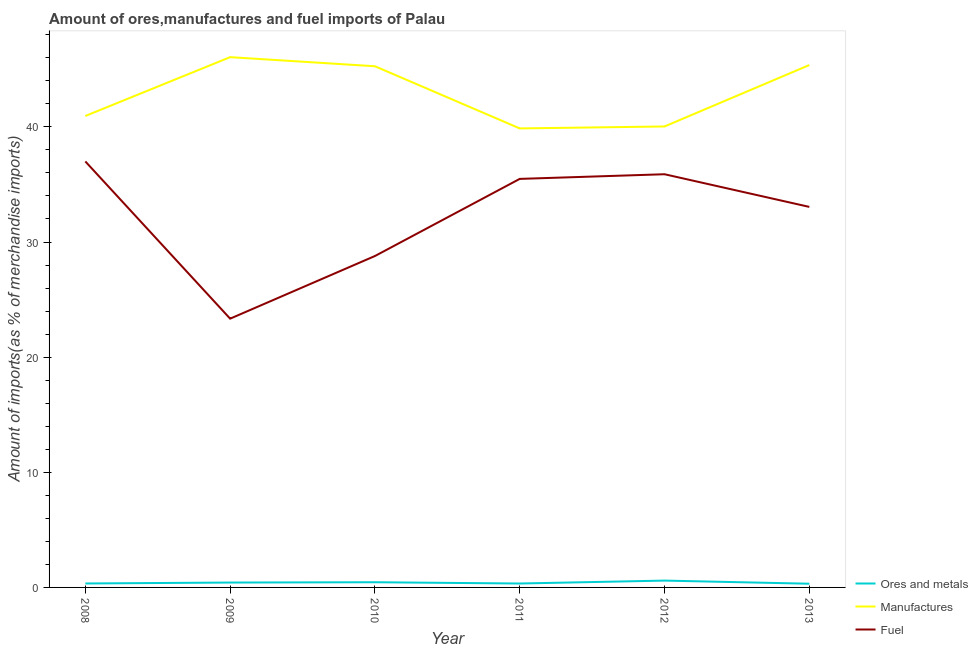How many different coloured lines are there?
Your answer should be very brief. 3. What is the percentage of fuel imports in 2012?
Provide a succinct answer. 35.89. Across all years, what is the maximum percentage of fuel imports?
Give a very brief answer. 37. Across all years, what is the minimum percentage of fuel imports?
Offer a very short reply. 23.34. In which year was the percentage of fuel imports maximum?
Provide a succinct answer. 2008. In which year was the percentage of manufactures imports minimum?
Make the answer very short. 2011. What is the total percentage of manufactures imports in the graph?
Offer a terse response. 257.54. What is the difference between the percentage of ores and metals imports in 2009 and that in 2010?
Your answer should be very brief. -0.03. What is the difference between the percentage of fuel imports in 2011 and the percentage of manufactures imports in 2009?
Make the answer very short. -10.57. What is the average percentage of fuel imports per year?
Your answer should be very brief. 32.26. In the year 2009, what is the difference between the percentage of manufactures imports and percentage of fuel imports?
Your response must be concise. 22.71. What is the ratio of the percentage of fuel imports in 2008 to that in 2009?
Offer a very short reply. 1.59. What is the difference between the highest and the second highest percentage of manufactures imports?
Keep it short and to the point. 0.69. What is the difference between the highest and the lowest percentage of manufactures imports?
Provide a succinct answer. 6.19. In how many years, is the percentage of manufactures imports greater than the average percentage of manufactures imports taken over all years?
Your response must be concise. 3. Does the percentage of manufactures imports monotonically increase over the years?
Your answer should be very brief. No. Is the percentage of ores and metals imports strictly greater than the percentage of fuel imports over the years?
Your answer should be very brief. No. How many years are there in the graph?
Your answer should be compact. 6. Are the values on the major ticks of Y-axis written in scientific E-notation?
Ensure brevity in your answer.  No. Does the graph contain any zero values?
Make the answer very short. No. Does the graph contain grids?
Your answer should be compact. No. Where does the legend appear in the graph?
Offer a very short reply. Bottom right. How many legend labels are there?
Give a very brief answer. 3. What is the title of the graph?
Your answer should be compact. Amount of ores,manufactures and fuel imports of Palau. What is the label or title of the Y-axis?
Keep it short and to the point. Amount of imports(as % of merchandise imports). What is the Amount of imports(as % of merchandise imports) in Ores and metals in 2008?
Provide a succinct answer. 0.34. What is the Amount of imports(as % of merchandise imports) of Manufactures in 2008?
Your answer should be compact. 40.95. What is the Amount of imports(as % of merchandise imports) of Fuel in 2008?
Your answer should be compact. 37. What is the Amount of imports(as % of merchandise imports) of Ores and metals in 2009?
Offer a terse response. 0.42. What is the Amount of imports(as % of merchandise imports) in Manufactures in 2009?
Make the answer very short. 46.06. What is the Amount of imports(as % of merchandise imports) of Fuel in 2009?
Give a very brief answer. 23.34. What is the Amount of imports(as % of merchandise imports) in Ores and metals in 2010?
Provide a short and direct response. 0.45. What is the Amount of imports(as % of merchandise imports) of Manufactures in 2010?
Ensure brevity in your answer.  45.27. What is the Amount of imports(as % of merchandise imports) in Fuel in 2010?
Your answer should be compact. 28.78. What is the Amount of imports(as % of merchandise imports) in Ores and metals in 2011?
Your response must be concise. 0.34. What is the Amount of imports(as % of merchandise imports) of Manufactures in 2011?
Make the answer very short. 39.87. What is the Amount of imports(as % of merchandise imports) in Fuel in 2011?
Keep it short and to the point. 35.48. What is the Amount of imports(as % of merchandise imports) in Ores and metals in 2012?
Ensure brevity in your answer.  0.59. What is the Amount of imports(as % of merchandise imports) of Manufactures in 2012?
Offer a terse response. 40.04. What is the Amount of imports(as % of merchandise imports) of Fuel in 2012?
Offer a very short reply. 35.89. What is the Amount of imports(as % of merchandise imports) of Ores and metals in 2013?
Ensure brevity in your answer.  0.32. What is the Amount of imports(as % of merchandise imports) of Manufactures in 2013?
Give a very brief answer. 45.37. What is the Amount of imports(as % of merchandise imports) in Fuel in 2013?
Ensure brevity in your answer.  33.05. Across all years, what is the maximum Amount of imports(as % of merchandise imports) of Ores and metals?
Provide a succinct answer. 0.59. Across all years, what is the maximum Amount of imports(as % of merchandise imports) of Manufactures?
Offer a very short reply. 46.06. Across all years, what is the maximum Amount of imports(as % of merchandise imports) of Fuel?
Provide a succinct answer. 37. Across all years, what is the minimum Amount of imports(as % of merchandise imports) of Ores and metals?
Give a very brief answer. 0.32. Across all years, what is the minimum Amount of imports(as % of merchandise imports) of Manufactures?
Your answer should be very brief. 39.87. Across all years, what is the minimum Amount of imports(as % of merchandise imports) in Fuel?
Give a very brief answer. 23.34. What is the total Amount of imports(as % of merchandise imports) of Ores and metals in the graph?
Provide a short and direct response. 2.47. What is the total Amount of imports(as % of merchandise imports) in Manufactures in the graph?
Your answer should be compact. 257.54. What is the total Amount of imports(as % of merchandise imports) of Fuel in the graph?
Give a very brief answer. 193.55. What is the difference between the Amount of imports(as % of merchandise imports) in Ores and metals in 2008 and that in 2009?
Ensure brevity in your answer.  -0.08. What is the difference between the Amount of imports(as % of merchandise imports) in Manufactures in 2008 and that in 2009?
Your answer should be compact. -5.11. What is the difference between the Amount of imports(as % of merchandise imports) of Fuel in 2008 and that in 2009?
Offer a very short reply. 13.66. What is the difference between the Amount of imports(as % of merchandise imports) of Ores and metals in 2008 and that in 2010?
Your response must be concise. -0.11. What is the difference between the Amount of imports(as % of merchandise imports) of Manufactures in 2008 and that in 2010?
Offer a terse response. -4.32. What is the difference between the Amount of imports(as % of merchandise imports) of Fuel in 2008 and that in 2010?
Provide a succinct answer. 8.21. What is the difference between the Amount of imports(as % of merchandise imports) in Ores and metals in 2008 and that in 2011?
Offer a terse response. 0. What is the difference between the Amount of imports(as % of merchandise imports) in Manufactures in 2008 and that in 2011?
Offer a very short reply. 1.08. What is the difference between the Amount of imports(as % of merchandise imports) in Fuel in 2008 and that in 2011?
Offer a terse response. 1.52. What is the difference between the Amount of imports(as % of merchandise imports) of Ores and metals in 2008 and that in 2012?
Give a very brief answer. -0.25. What is the difference between the Amount of imports(as % of merchandise imports) in Manufactures in 2008 and that in 2012?
Make the answer very short. 0.91. What is the difference between the Amount of imports(as % of merchandise imports) of Fuel in 2008 and that in 2012?
Ensure brevity in your answer.  1.11. What is the difference between the Amount of imports(as % of merchandise imports) in Ores and metals in 2008 and that in 2013?
Your answer should be very brief. 0.02. What is the difference between the Amount of imports(as % of merchandise imports) of Manufactures in 2008 and that in 2013?
Offer a terse response. -4.42. What is the difference between the Amount of imports(as % of merchandise imports) in Fuel in 2008 and that in 2013?
Your answer should be very brief. 3.95. What is the difference between the Amount of imports(as % of merchandise imports) in Ores and metals in 2009 and that in 2010?
Your answer should be very brief. -0.03. What is the difference between the Amount of imports(as % of merchandise imports) in Manufactures in 2009 and that in 2010?
Offer a very short reply. 0.79. What is the difference between the Amount of imports(as % of merchandise imports) in Fuel in 2009 and that in 2010?
Provide a succinct answer. -5.44. What is the difference between the Amount of imports(as % of merchandise imports) in Ores and metals in 2009 and that in 2011?
Provide a short and direct response. 0.08. What is the difference between the Amount of imports(as % of merchandise imports) in Manufactures in 2009 and that in 2011?
Provide a short and direct response. 6.19. What is the difference between the Amount of imports(as % of merchandise imports) in Fuel in 2009 and that in 2011?
Ensure brevity in your answer.  -12.14. What is the difference between the Amount of imports(as % of merchandise imports) of Ores and metals in 2009 and that in 2012?
Make the answer very short. -0.17. What is the difference between the Amount of imports(as % of merchandise imports) of Manufactures in 2009 and that in 2012?
Make the answer very short. 6.02. What is the difference between the Amount of imports(as % of merchandise imports) in Fuel in 2009 and that in 2012?
Make the answer very short. -12.54. What is the difference between the Amount of imports(as % of merchandise imports) in Ores and metals in 2009 and that in 2013?
Give a very brief answer. 0.1. What is the difference between the Amount of imports(as % of merchandise imports) of Manufactures in 2009 and that in 2013?
Offer a terse response. 0.69. What is the difference between the Amount of imports(as % of merchandise imports) in Fuel in 2009 and that in 2013?
Provide a succinct answer. -9.71. What is the difference between the Amount of imports(as % of merchandise imports) in Ores and metals in 2010 and that in 2011?
Keep it short and to the point. 0.11. What is the difference between the Amount of imports(as % of merchandise imports) of Manufactures in 2010 and that in 2011?
Keep it short and to the point. 5.4. What is the difference between the Amount of imports(as % of merchandise imports) of Fuel in 2010 and that in 2011?
Give a very brief answer. -6.7. What is the difference between the Amount of imports(as % of merchandise imports) of Ores and metals in 2010 and that in 2012?
Give a very brief answer. -0.14. What is the difference between the Amount of imports(as % of merchandise imports) in Manufactures in 2010 and that in 2012?
Make the answer very short. 5.23. What is the difference between the Amount of imports(as % of merchandise imports) of Fuel in 2010 and that in 2012?
Ensure brevity in your answer.  -7.1. What is the difference between the Amount of imports(as % of merchandise imports) in Ores and metals in 2010 and that in 2013?
Provide a succinct answer. 0.13. What is the difference between the Amount of imports(as % of merchandise imports) of Manufactures in 2010 and that in 2013?
Your response must be concise. -0.1. What is the difference between the Amount of imports(as % of merchandise imports) of Fuel in 2010 and that in 2013?
Give a very brief answer. -4.27. What is the difference between the Amount of imports(as % of merchandise imports) in Ores and metals in 2011 and that in 2012?
Provide a succinct answer. -0.25. What is the difference between the Amount of imports(as % of merchandise imports) of Manufactures in 2011 and that in 2012?
Ensure brevity in your answer.  -0.17. What is the difference between the Amount of imports(as % of merchandise imports) of Fuel in 2011 and that in 2012?
Your answer should be compact. -0.4. What is the difference between the Amount of imports(as % of merchandise imports) in Ores and metals in 2011 and that in 2013?
Make the answer very short. 0.02. What is the difference between the Amount of imports(as % of merchandise imports) of Manufactures in 2011 and that in 2013?
Your response must be concise. -5.5. What is the difference between the Amount of imports(as % of merchandise imports) of Fuel in 2011 and that in 2013?
Make the answer very short. 2.43. What is the difference between the Amount of imports(as % of merchandise imports) in Ores and metals in 2012 and that in 2013?
Provide a short and direct response. 0.27. What is the difference between the Amount of imports(as % of merchandise imports) in Manufactures in 2012 and that in 2013?
Offer a terse response. -5.33. What is the difference between the Amount of imports(as % of merchandise imports) of Fuel in 2012 and that in 2013?
Give a very brief answer. 2.84. What is the difference between the Amount of imports(as % of merchandise imports) in Ores and metals in 2008 and the Amount of imports(as % of merchandise imports) in Manufactures in 2009?
Offer a very short reply. -45.71. What is the difference between the Amount of imports(as % of merchandise imports) of Ores and metals in 2008 and the Amount of imports(as % of merchandise imports) of Fuel in 2009?
Offer a terse response. -23. What is the difference between the Amount of imports(as % of merchandise imports) of Manufactures in 2008 and the Amount of imports(as % of merchandise imports) of Fuel in 2009?
Your answer should be compact. 17.6. What is the difference between the Amount of imports(as % of merchandise imports) in Ores and metals in 2008 and the Amount of imports(as % of merchandise imports) in Manufactures in 2010?
Make the answer very short. -44.92. What is the difference between the Amount of imports(as % of merchandise imports) in Ores and metals in 2008 and the Amount of imports(as % of merchandise imports) in Fuel in 2010?
Offer a terse response. -28.44. What is the difference between the Amount of imports(as % of merchandise imports) in Manufactures in 2008 and the Amount of imports(as % of merchandise imports) in Fuel in 2010?
Give a very brief answer. 12.16. What is the difference between the Amount of imports(as % of merchandise imports) in Ores and metals in 2008 and the Amount of imports(as % of merchandise imports) in Manufactures in 2011?
Your answer should be compact. -39.52. What is the difference between the Amount of imports(as % of merchandise imports) of Ores and metals in 2008 and the Amount of imports(as % of merchandise imports) of Fuel in 2011?
Make the answer very short. -35.14. What is the difference between the Amount of imports(as % of merchandise imports) in Manufactures in 2008 and the Amount of imports(as % of merchandise imports) in Fuel in 2011?
Make the answer very short. 5.46. What is the difference between the Amount of imports(as % of merchandise imports) in Ores and metals in 2008 and the Amount of imports(as % of merchandise imports) in Manufactures in 2012?
Your response must be concise. -39.69. What is the difference between the Amount of imports(as % of merchandise imports) of Ores and metals in 2008 and the Amount of imports(as % of merchandise imports) of Fuel in 2012?
Offer a very short reply. -35.55. What is the difference between the Amount of imports(as % of merchandise imports) in Manufactures in 2008 and the Amount of imports(as % of merchandise imports) in Fuel in 2012?
Keep it short and to the point. 5.06. What is the difference between the Amount of imports(as % of merchandise imports) in Ores and metals in 2008 and the Amount of imports(as % of merchandise imports) in Manufactures in 2013?
Keep it short and to the point. -45.03. What is the difference between the Amount of imports(as % of merchandise imports) of Ores and metals in 2008 and the Amount of imports(as % of merchandise imports) of Fuel in 2013?
Your answer should be compact. -32.71. What is the difference between the Amount of imports(as % of merchandise imports) of Manufactures in 2008 and the Amount of imports(as % of merchandise imports) of Fuel in 2013?
Provide a short and direct response. 7.9. What is the difference between the Amount of imports(as % of merchandise imports) in Ores and metals in 2009 and the Amount of imports(as % of merchandise imports) in Manufactures in 2010?
Offer a terse response. -44.84. What is the difference between the Amount of imports(as % of merchandise imports) in Ores and metals in 2009 and the Amount of imports(as % of merchandise imports) in Fuel in 2010?
Offer a very short reply. -28.36. What is the difference between the Amount of imports(as % of merchandise imports) in Manufactures in 2009 and the Amount of imports(as % of merchandise imports) in Fuel in 2010?
Make the answer very short. 17.27. What is the difference between the Amount of imports(as % of merchandise imports) of Ores and metals in 2009 and the Amount of imports(as % of merchandise imports) of Manufactures in 2011?
Ensure brevity in your answer.  -39.44. What is the difference between the Amount of imports(as % of merchandise imports) in Ores and metals in 2009 and the Amount of imports(as % of merchandise imports) in Fuel in 2011?
Ensure brevity in your answer.  -35.06. What is the difference between the Amount of imports(as % of merchandise imports) in Manufactures in 2009 and the Amount of imports(as % of merchandise imports) in Fuel in 2011?
Provide a succinct answer. 10.57. What is the difference between the Amount of imports(as % of merchandise imports) in Ores and metals in 2009 and the Amount of imports(as % of merchandise imports) in Manufactures in 2012?
Your answer should be compact. -39.61. What is the difference between the Amount of imports(as % of merchandise imports) in Ores and metals in 2009 and the Amount of imports(as % of merchandise imports) in Fuel in 2012?
Make the answer very short. -35.46. What is the difference between the Amount of imports(as % of merchandise imports) in Manufactures in 2009 and the Amount of imports(as % of merchandise imports) in Fuel in 2012?
Your response must be concise. 10.17. What is the difference between the Amount of imports(as % of merchandise imports) of Ores and metals in 2009 and the Amount of imports(as % of merchandise imports) of Manufactures in 2013?
Offer a very short reply. -44.95. What is the difference between the Amount of imports(as % of merchandise imports) of Ores and metals in 2009 and the Amount of imports(as % of merchandise imports) of Fuel in 2013?
Offer a terse response. -32.63. What is the difference between the Amount of imports(as % of merchandise imports) in Manufactures in 2009 and the Amount of imports(as % of merchandise imports) in Fuel in 2013?
Your answer should be compact. 13.01. What is the difference between the Amount of imports(as % of merchandise imports) in Ores and metals in 2010 and the Amount of imports(as % of merchandise imports) in Manufactures in 2011?
Make the answer very short. -39.42. What is the difference between the Amount of imports(as % of merchandise imports) in Ores and metals in 2010 and the Amount of imports(as % of merchandise imports) in Fuel in 2011?
Provide a short and direct response. -35.03. What is the difference between the Amount of imports(as % of merchandise imports) in Manufactures in 2010 and the Amount of imports(as % of merchandise imports) in Fuel in 2011?
Keep it short and to the point. 9.78. What is the difference between the Amount of imports(as % of merchandise imports) of Ores and metals in 2010 and the Amount of imports(as % of merchandise imports) of Manufactures in 2012?
Ensure brevity in your answer.  -39.59. What is the difference between the Amount of imports(as % of merchandise imports) of Ores and metals in 2010 and the Amount of imports(as % of merchandise imports) of Fuel in 2012?
Provide a succinct answer. -35.44. What is the difference between the Amount of imports(as % of merchandise imports) of Manufactures in 2010 and the Amount of imports(as % of merchandise imports) of Fuel in 2012?
Your answer should be very brief. 9.38. What is the difference between the Amount of imports(as % of merchandise imports) in Ores and metals in 2010 and the Amount of imports(as % of merchandise imports) in Manufactures in 2013?
Keep it short and to the point. -44.92. What is the difference between the Amount of imports(as % of merchandise imports) of Ores and metals in 2010 and the Amount of imports(as % of merchandise imports) of Fuel in 2013?
Offer a terse response. -32.6. What is the difference between the Amount of imports(as % of merchandise imports) of Manufactures in 2010 and the Amount of imports(as % of merchandise imports) of Fuel in 2013?
Your answer should be compact. 12.22. What is the difference between the Amount of imports(as % of merchandise imports) in Ores and metals in 2011 and the Amount of imports(as % of merchandise imports) in Manufactures in 2012?
Provide a succinct answer. -39.7. What is the difference between the Amount of imports(as % of merchandise imports) of Ores and metals in 2011 and the Amount of imports(as % of merchandise imports) of Fuel in 2012?
Give a very brief answer. -35.55. What is the difference between the Amount of imports(as % of merchandise imports) in Manufactures in 2011 and the Amount of imports(as % of merchandise imports) in Fuel in 2012?
Offer a very short reply. 3.98. What is the difference between the Amount of imports(as % of merchandise imports) of Ores and metals in 2011 and the Amount of imports(as % of merchandise imports) of Manufactures in 2013?
Offer a terse response. -45.03. What is the difference between the Amount of imports(as % of merchandise imports) in Ores and metals in 2011 and the Amount of imports(as % of merchandise imports) in Fuel in 2013?
Provide a short and direct response. -32.71. What is the difference between the Amount of imports(as % of merchandise imports) of Manufactures in 2011 and the Amount of imports(as % of merchandise imports) of Fuel in 2013?
Your answer should be very brief. 6.82. What is the difference between the Amount of imports(as % of merchandise imports) in Ores and metals in 2012 and the Amount of imports(as % of merchandise imports) in Manufactures in 2013?
Provide a succinct answer. -44.78. What is the difference between the Amount of imports(as % of merchandise imports) in Ores and metals in 2012 and the Amount of imports(as % of merchandise imports) in Fuel in 2013?
Your response must be concise. -32.46. What is the difference between the Amount of imports(as % of merchandise imports) of Manufactures in 2012 and the Amount of imports(as % of merchandise imports) of Fuel in 2013?
Offer a terse response. 6.99. What is the average Amount of imports(as % of merchandise imports) of Ores and metals per year?
Keep it short and to the point. 0.41. What is the average Amount of imports(as % of merchandise imports) in Manufactures per year?
Your answer should be compact. 42.92. What is the average Amount of imports(as % of merchandise imports) in Fuel per year?
Ensure brevity in your answer.  32.26. In the year 2008, what is the difference between the Amount of imports(as % of merchandise imports) of Ores and metals and Amount of imports(as % of merchandise imports) of Manufactures?
Make the answer very short. -40.61. In the year 2008, what is the difference between the Amount of imports(as % of merchandise imports) of Ores and metals and Amount of imports(as % of merchandise imports) of Fuel?
Your response must be concise. -36.66. In the year 2008, what is the difference between the Amount of imports(as % of merchandise imports) of Manufactures and Amount of imports(as % of merchandise imports) of Fuel?
Your response must be concise. 3.95. In the year 2009, what is the difference between the Amount of imports(as % of merchandise imports) in Ores and metals and Amount of imports(as % of merchandise imports) in Manufactures?
Provide a short and direct response. -45.63. In the year 2009, what is the difference between the Amount of imports(as % of merchandise imports) in Ores and metals and Amount of imports(as % of merchandise imports) in Fuel?
Keep it short and to the point. -22.92. In the year 2009, what is the difference between the Amount of imports(as % of merchandise imports) in Manufactures and Amount of imports(as % of merchandise imports) in Fuel?
Offer a terse response. 22.71. In the year 2010, what is the difference between the Amount of imports(as % of merchandise imports) of Ores and metals and Amount of imports(as % of merchandise imports) of Manufactures?
Provide a short and direct response. -44.82. In the year 2010, what is the difference between the Amount of imports(as % of merchandise imports) of Ores and metals and Amount of imports(as % of merchandise imports) of Fuel?
Provide a succinct answer. -28.33. In the year 2010, what is the difference between the Amount of imports(as % of merchandise imports) in Manufactures and Amount of imports(as % of merchandise imports) in Fuel?
Offer a very short reply. 16.48. In the year 2011, what is the difference between the Amount of imports(as % of merchandise imports) of Ores and metals and Amount of imports(as % of merchandise imports) of Manufactures?
Keep it short and to the point. -39.53. In the year 2011, what is the difference between the Amount of imports(as % of merchandise imports) of Ores and metals and Amount of imports(as % of merchandise imports) of Fuel?
Your response must be concise. -35.14. In the year 2011, what is the difference between the Amount of imports(as % of merchandise imports) in Manufactures and Amount of imports(as % of merchandise imports) in Fuel?
Offer a very short reply. 4.38. In the year 2012, what is the difference between the Amount of imports(as % of merchandise imports) in Ores and metals and Amount of imports(as % of merchandise imports) in Manufactures?
Ensure brevity in your answer.  -39.44. In the year 2012, what is the difference between the Amount of imports(as % of merchandise imports) of Ores and metals and Amount of imports(as % of merchandise imports) of Fuel?
Make the answer very short. -35.29. In the year 2012, what is the difference between the Amount of imports(as % of merchandise imports) in Manufactures and Amount of imports(as % of merchandise imports) in Fuel?
Offer a very short reply. 4.15. In the year 2013, what is the difference between the Amount of imports(as % of merchandise imports) in Ores and metals and Amount of imports(as % of merchandise imports) in Manufactures?
Your answer should be very brief. -45.05. In the year 2013, what is the difference between the Amount of imports(as % of merchandise imports) of Ores and metals and Amount of imports(as % of merchandise imports) of Fuel?
Your response must be concise. -32.73. In the year 2013, what is the difference between the Amount of imports(as % of merchandise imports) in Manufactures and Amount of imports(as % of merchandise imports) in Fuel?
Ensure brevity in your answer.  12.32. What is the ratio of the Amount of imports(as % of merchandise imports) in Ores and metals in 2008 to that in 2009?
Ensure brevity in your answer.  0.81. What is the ratio of the Amount of imports(as % of merchandise imports) in Manufactures in 2008 to that in 2009?
Your answer should be compact. 0.89. What is the ratio of the Amount of imports(as % of merchandise imports) in Fuel in 2008 to that in 2009?
Keep it short and to the point. 1.58. What is the ratio of the Amount of imports(as % of merchandise imports) of Ores and metals in 2008 to that in 2010?
Provide a succinct answer. 0.76. What is the ratio of the Amount of imports(as % of merchandise imports) in Manufactures in 2008 to that in 2010?
Your response must be concise. 0.9. What is the ratio of the Amount of imports(as % of merchandise imports) of Fuel in 2008 to that in 2010?
Keep it short and to the point. 1.29. What is the ratio of the Amount of imports(as % of merchandise imports) in Manufactures in 2008 to that in 2011?
Keep it short and to the point. 1.03. What is the ratio of the Amount of imports(as % of merchandise imports) in Fuel in 2008 to that in 2011?
Offer a terse response. 1.04. What is the ratio of the Amount of imports(as % of merchandise imports) of Ores and metals in 2008 to that in 2012?
Ensure brevity in your answer.  0.58. What is the ratio of the Amount of imports(as % of merchandise imports) in Manufactures in 2008 to that in 2012?
Provide a short and direct response. 1.02. What is the ratio of the Amount of imports(as % of merchandise imports) of Fuel in 2008 to that in 2012?
Make the answer very short. 1.03. What is the ratio of the Amount of imports(as % of merchandise imports) of Ores and metals in 2008 to that in 2013?
Your answer should be very brief. 1.06. What is the ratio of the Amount of imports(as % of merchandise imports) of Manufactures in 2008 to that in 2013?
Provide a short and direct response. 0.9. What is the ratio of the Amount of imports(as % of merchandise imports) of Fuel in 2008 to that in 2013?
Offer a terse response. 1.12. What is the ratio of the Amount of imports(as % of merchandise imports) in Ores and metals in 2009 to that in 2010?
Ensure brevity in your answer.  0.94. What is the ratio of the Amount of imports(as % of merchandise imports) in Manufactures in 2009 to that in 2010?
Your answer should be compact. 1.02. What is the ratio of the Amount of imports(as % of merchandise imports) in Fuel in 2009 to that in 2010?
Provide a short and direct response. 0.81. What is the ratio of the Amount of imports(as % of merchandise imports) of Ores and metals in 2009 to that in 2011?
Your answer should be very brief. 1.24. What is the ratio of the Amount of imports(as % of merchandise imports) in Manufactures in 2009 to that in 2011?
Ensure brevity in your answer.  1.16. What is the ratio of the Amount of imports(as % of merchandise imports) in Fuel in 2009 to that in 2011?
Keep it short and to the point. 0.66. What is the ratio of the Amount of imports(as % of merchandise imports) of Ores and metals in 2009 to that in 2012?
Offer a terse response. 0.71. What is the ratio of the Amount of imports(as % of merchandise imports) in Manufactures in 2009 to that in 2012?
Your answer should be very brief. 1.15. What is the ratio of the Amount of imports(as % of merchandise imports) of Fuel in 2009 to that in 2012?
Offer a very short reply. 0.65. What is the ratio of the Amount of imports(as % of merchandise imports) in Ores and metals in 2009 to that in 2013?
Provide a short and direct response. 1.32. What is the ratio of the Amount of imports(as % of merchandise imports) of Manufactures in 2009 to that in 2013?
Ensure brevity in your answer.  1.02. What is the ratio of the Amount of imports(as % of merchandise imports) in Fuel in 2009 to that in 2013?
Your answer should be very brief. 0.71. What is the ratio of the Amount of imports(as % of merchandise imports) of Ores and metals in 2010 to that in 2011?
Provide a short and direct response. 1.32. What is the ratio of the Amount of imports(as % of merchandise imports) in Manufactures in 2010 to that in 2011?
Give a very brief answer. 1.14. What is the ratio of the Amount of imports(as % of merchandise imports) of Fuel in 2010 to that in 2011?
Keep it short and to the point. 0.81. What is the ratio of the Amount of imports(as % of merchandise imports) of Ores and metals in 2010 to that in 2012?
Your response must be concise. 0.76. What is the ratio of the Amount of imports(as % of merchandise imports) of Manufactures in 2010 to that in 2012?
Provide a short and direct response. 1.13. What is the ratio of the Amount of imports(as % of merchandise imports) in Fuel in 2010 to that in 2012?
Keep it short and to the point. 0.8. What is the ratio of the Amount of imports(as % of merchandise imports) of Ores and metals in 2010 to that in 2013?
Provide a short and direct response. 1.4. What is the ratio of the Amount of imports(as % of merchandise imports) of Fuel in 2010 to that in 2013?
Provide a succinct answer. 0.87. What is the ratio of the Amount of imports(as % of merchandise imports) in Ores and metals in 2011 to that in 2012?
Ensure brevity in your answer.  0.57. What is the ratio of the Amount of imports(as % of merchandise imports) of Fuel in 2011 to that in 2012?
Provide a succinct answer. 0.99. What is the ratio of the Amount of imports(as % of merchandise imports) of Ores and metals in 2011 to that in 2013?
Your response must be concise. 1.06. What is the ratio of the Amount of imports(as % of merchandise imports) in Manufactures in 2011 to that in 2013?
Ensure brevity in your answer.  0.88. What is the ratio of the Amount of imports(as % of merchandise imports) in Fuel in 2011 to that in 2013?
Give a very brief answer. 1.07. What is the ratio of the Amount of imports(as % of merchandise imports) of Ores and metals in 2012 to that in 2013?
Provide a short and direct response. 1.84. What is the ratio of the Amount of imports(as % of merchandise imports) of Manufactures in 2012 to that in 2013?
Offer a terse response. 0.88. What is the ratio of the Amount of imports(as % of merchandise imports) of Fuel in 2012 to that in 2013?
Your response must be concise. 1.09. What is the difference between the highest and the second highest Amount of imports(as % of merchandise imports) of Ores and metals?
Offer a very short reply. 0.14. What is the difference between the highest and the second highest Amount of imports(as % of merchandise imports) in Manufactures?
Provide a succinct answer. 0.69. What is the difference between the highest and the second highest Amount of imports(as % of merchandise imports) of Fuel?
Offer a terse response. 1.11. What is the difference between the highest and the lowest Amount of imports(as % of merchandise imports) of Ores and metals?
Offer a very short reply. 0.27. What is the difference between the highest and the lowest Amount of imports(as % of merchandise imports) of Manufactures?
Provide a short and direct response. 6.19. What is the difference between the highest and the lowest Amount of imports(as % of merchandise imports) in Fuel?
Ensure brevity in your answer.  13.66. 